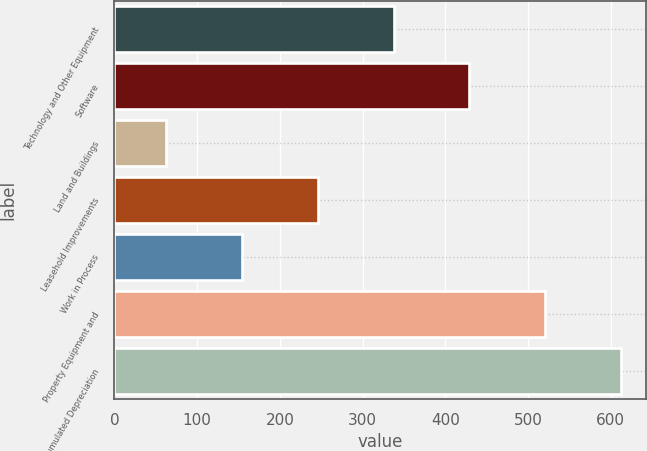<chart> <loc_0><loc_0><loc_500><loc_500><bar_chart><fcel>Technology and Other Equipment<fcel>Software<fcel>Land and Buildings<fcel>Leasehold Improvements<fcel>Work in Process<fcel>Property Equipment and<fcel>Less Accumulated Depreciation<nl><fcel>337.49<fcel>429.22<fcel>62.3<fcel>245.76<fcel>154.03<fcel>520.95<fcel>612.68<nl></chart> 